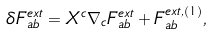<formula> <loc_0><loc_0><loc_500><loc_500>\delta F ^ { e x t } _ { a b } = X ^ { c } \nabla _ { c } F ^ { e x t } _ { a b } + F ^ { e x t , ( 1 ) } _ { a b } ,</formula> 